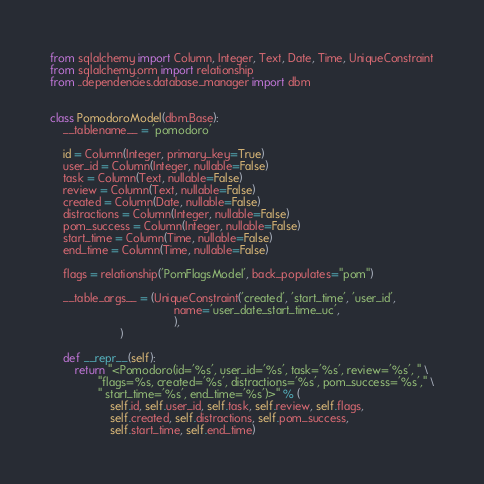<code> <loc_0><loc_0><loc_500><loc_500><_Python_>from sqlalchemy import Column, Integer, Text, Date, Time, UniqueConstraint
from sqlalchemy.orm import relationship
from ..dependencies.database_manager import dbm


class PomodoroModel(dbm.Base):
    __tablename__ = 'pomodoro'

    id = Column(Integer, primary_key=True)
    user_id = Column(Integer, nullable=False)
    task = Column(Text, nullable=False)
    review = Column(Text, nullable=False)
    created = Column(Date, nullable=False)
    distractions = Column(Integer, nullable=False)
    pom_success = Column(Integer, nullable=False)
    start_time = Column(Time, nullable=False)
    end_time = Column(Time, nullable=False)

    flags = relationship('PomFlagsModel', back_populates="pom")

    __table_args__ = (UniqueConstraint('created', 'start_time', 'user_id',
                                       name='user_date_start_time_uc',
                                       ),
                      )

    def __repr__(self):
        return "<Pomodoro(id='%s', user_id='%s', task='%s', review='%s', " \
               "flags=%s, created='%s', distractions='%s', pom_success='%s'," \
               " start_time='%s', end_time='%s')>" % (
                   self.id, self.user_id, self.task, self.review, self.flags,
                   self.created, self.distractions, self.pom_success,
                   self.start_time, self.end_time)
</code> 